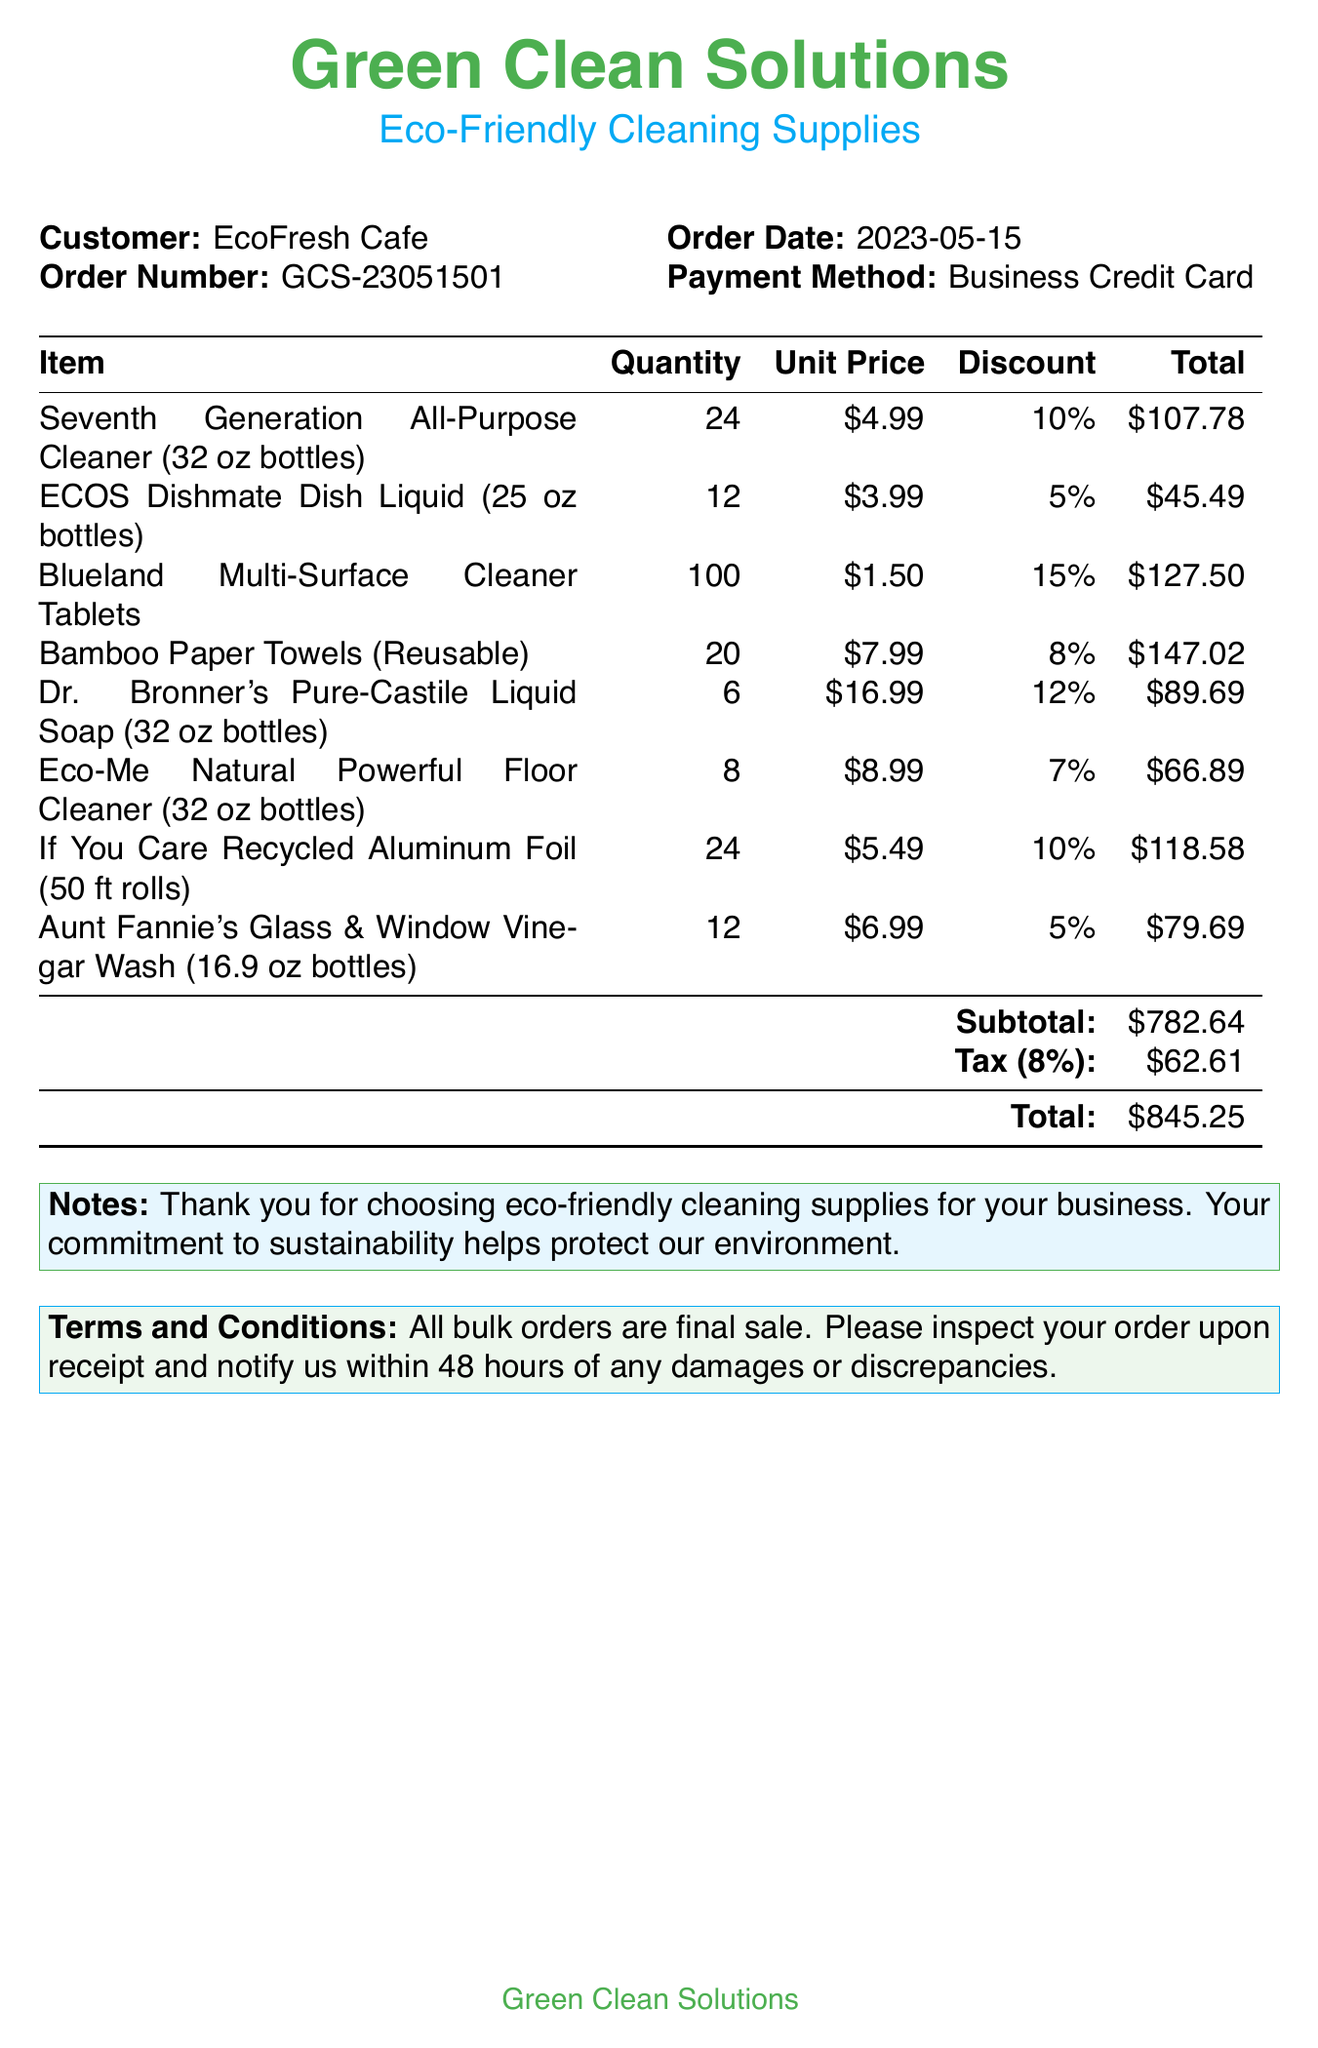What is the business name? The business name is listed at the top of the document, indicating who is issuing the receipt.
Answer: Green Clean Solutions What is the order date? The order date is specified in the header section of the receipt.
Answer: 2023-05-15 What is the total amount after tax? The total amount is calculated at the end of the receipt, summarizing the entire purchase.
Answer: $845.25 How many units of the Blueland Multi-Surface Cleaner Tablets were ordered? The quantity of the item is stated in the itemized list on the receipt.
Answer: 100 What discount was applied to the Bamboo Paper Towels? The discount is indicated alongside the item in the receipt.
Answer: 8% What is the subtotal before tax? The subtotal is provided before calculating tax at the bottom of the itemized list.
Answer: $782.64 What item has the highest unit price? To find the highest unit price, compare the prices listed per unit for each item.
Answer: Dr. Bronner's Pure-Castile Liquid Soap What payment method was used for this order? The payment method is mentioned in the header section of the receipt.
Answer: Business Credit Card What should be done if there are discrepancies upon receipt? The terms and conditions section provides instructions for handling discrepancies.
Answer: Notify us within 48 hours 